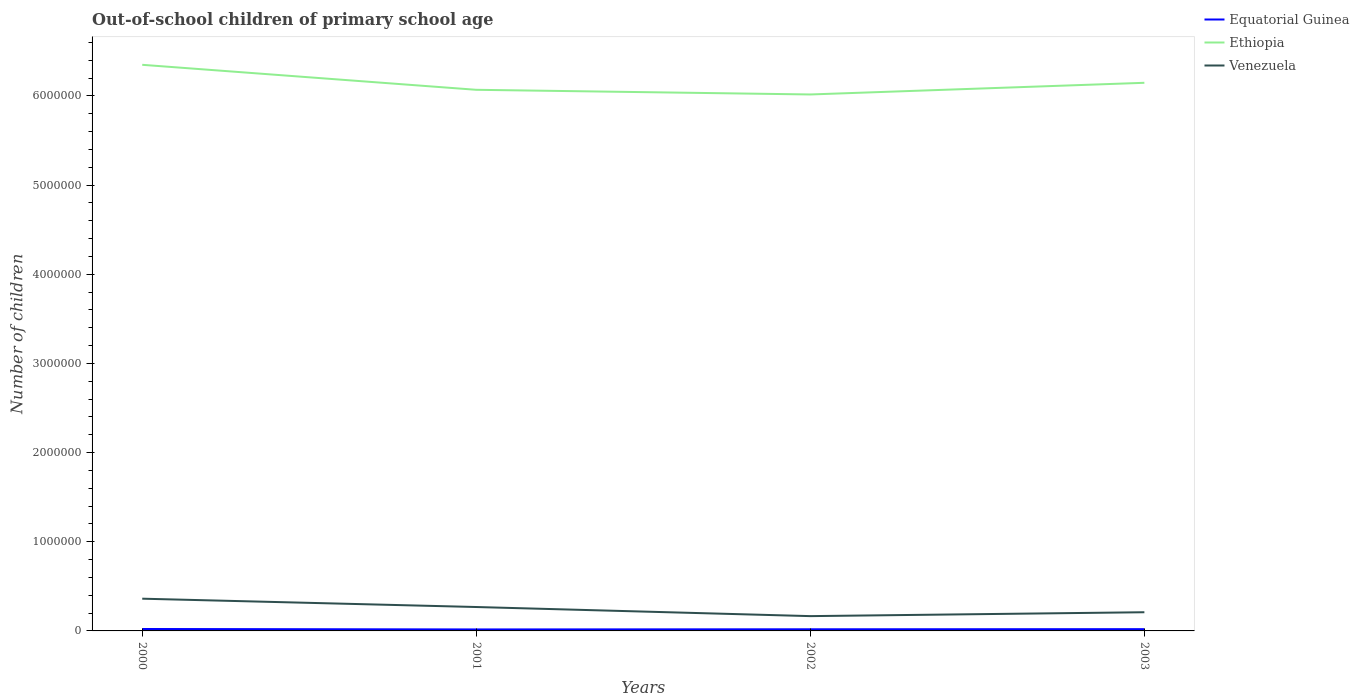How many different coloured lines are there?
Offer a terse response. 3. Does the line corresponding to Equatorial Guinea intersect with the line corresponding to Ethiopia?
Make the answer very short. No. Across all years, what is the maximum number of out-of-school children in Venezuela?
Give a very brief answer. 1.66e+05. What is the total number of out-of-school children in Ethiopia in the graph?
Offer a terse response. 5.23e+04. What is the difference between the highest and the second highest number of out-of-school children in Equatorial Guinea?
Ensure brevity in your answer.  4929. What is the difference between the highest and the lowest number of out-of-school children in Equatorial Guinea?
Offer a very short reply. 2. Is the number of out-of-school children in Equatorial Guinea strictly greater than the number of out-of-school children in Venezuela over the years?
Give a very brief answer. Yes. How many lines are there?
Ensure brevity in your answer.  3. What is the difference between two consecutive major ticks on the Y-axis?
Offer a terse response. 1.00e+06. Does the graph contain grids?
Your response must be concise. No. How are the legend labels stacked?
Keep it short and to the point. Vertical. What is the title of the graph?
Your answer should be very brief. Out-of-school children of primary school age. Does "Guatemala" appear as one of the legend labels in the graph?
Ensure brevity in your answer.  No. What is the label or title of the Y-axis?
Offer a terse response. Number of children. What is the Number of children in Equatorial Guinea in 2000?
Offer a terse response. 2.16e+04. What is the Number of children of Ethiopia in 2000?
Offer a terse response. 6.35e+06. What is the Number of children of Venezuela in 2000?
Offer a very short reply. 3.62e+05. What is the Number of children in Equatorial Guinea in 2001?
Keep it short and to the point. 1.67e+04. What is the Number of children of Ethiopia in 2001?
Ensure brevity in your answer.  6.07e+06. What is the Number of children in Venezuela in 2001?
Your answer should be compact. 2.68e+05. What is the Number of children of Equatorial Guinea in 2002?
Offer a very short reply. 1.84e+04. What is the Number of children of Ethiopia in 2002?
Give a very brief answer. 6.02e+06. What is the Number of children in Venezuela in 2002?
Provide a succinct answer. 1.66e+05. What is the Number of children in Equatorial Guinea in 2003?
Offer a very short reply. 1.98e+04. What is the Number of children of Ethiopia in 2003?
Provide a short and direct response. 6.15e+06. What is the Number of children of Venezuela in 2003?
Your answer should be very brief. 2.10e+05. Across all years, what is the maximum Number of children in Equatorial Guinea?
Provide a succinct answer. 2.16e+04. Across all years, what is the maximum Number of children of Ethiopia?
Give a very brief answer. 6.35e+06. Across all years, what is the maximum Number of children of Venezuela?
Ensure brevity in your answer.  3.62e+05. Across all years, what is the minimum Number of children of Equatorial Guinea?
Your answer should be compact. 1.67e+04. Across all years, what is the minimum Number of children of Ethiopia?
Give a very brief answer. 6.02e+06. Across all years, what is the minimum Number of children in Venezuela?
Keep it short and to the point. 1.66e+05. What is the total Number of children in Equatorial Guinea in the graph?
Make the answer very short. 7.65e+04. What is the total Number of children in Ethiopia in the graph?
Your answer should be compact. 2.46e+07. What is the total Number of children in Venezuela in the graph?
Make the answer very short. 1.01e+06. What is the difference between the Number of children of Equatorial Guinea in 2000 and that in 2001?
Your answer should be very brief. 4929. What is the difference between the Number of children of Ethiopia in 2000 and that in 2001?
Your response must be concise. 2.80e+05. What is the difference between the Number of children of Venezuela in 2000 and that in 2001?
Your response must be concise. 9.35e+04. What is the difference between the Number of children of Equatorial Guinea in 2000 and that in 2002?
Offer a very short reply. 3176. What is the difference between the Number of children in Ethiopia in 2000 and that in 2002?
Your response must be concise. 3.33e+05. What is the difference between the Number of children in Venezuela in 2000 and that in 2002?
Provide a short and direct response. 1.96e+05. What is the difference between the Number of children of Equatorial Guinea in 2000 and that in 2003?
Your response must be concise. 1792. What is the difference between the Number of children in Ethiopia in 2000 and that in 2003?
Offer a terse response. 2.02e+05. What is the difference between the Number of children in Venezuela in 2000 and that in 2003?
Ensure brevity in your answer.  1.52e+05. What is the difference between the Number of children in Equatorial Guinea in 2001 and that in 2002?
Provide a succinct answer. -1753. What is the difference between the Number of children in Ethiopia in 2001 and that in 2002?
Your answer should be compact. 5.23e+04. What is the difference between the Number of children of Venezuela in 2001 and that in 2002?
Provide a short and direct response. 1.02e+05. What is the difference between the Number of children in Equatorial Guinea in 2001 and that in 2003?
Keep it short and to the point. -3137. What is the difference between the Number of children in Ethiopia in 2001 and that in 2003?
Offer a very short reply. -7.86e+04. What is the difference between the Number of children in Venezuela in 2001 and that in 2003?
Ensure brevity in your answer.  5.85e+04. What is the difference between the Number of children of Equatorial Guinea in 2002 and that in 2003?
Offer a terse response. -1384. What is the difference between the Number of children in Ethiopia in 2002 and that in 2003?
Your answer should be very brief. -1.31e+05. What is the difference between the Number of children in Venezuela in 2002 and that in 2003?
Provide a short and direct response. -4.36e+04. What is the difference between the Number of children of Equatorial Guinea in 2000 and the Number of children of Ethiopia in 2001?
Your answer should be very brief. -6.05e+06. What is the difference between the Number of children in Equatorial Guinea in 2000 and the Number of children in Venezuela in 2001?
Make the answer very short. -2.47e+05. What is the difference between the Number of children in Ethiopia in 2000 and the Number of children in Venezuela in 2001?
Give a very brief answer. 6.08e+06. What is the difference between the Number of children of Equatorial Guinea in 2000 and the Number of children of Ethiopia in 2002?
Offer a terse response. -5.99e+06. What is the difference between the Number of children of Equatorial Guinea in 2000 and the Number of children of Venezuela in 2002?
Provide a succinct answer. -1.44e+05. What is the difference between the Number of children in Ethiopia in 2000 and the Number of children in Venezuela in 2002?
Offer a very short reply. 6.18e+06. What is the difference between the Number of children of Equatorial Guinea in 2000 and the Number of children of Ethiopia in 2003?
Provide a short and direct response. -6.13e+06. What is the difference between the Number of children in Equatorial Guinea in 2000 and the Number of children in Venezuela in 2003?
Provide a short and direct response. -1.88e+05. What is the difference between the Number of children of Ethiopia in 2000 and the Number of children of Venezuela in 2003?
Your answer should be compact. 6.14e+06. What is the difference between the Number of children of Equatorial Guinea in 2001 and the Number of children of Ethiopia in 2002?
Give a very brief answer. -6.00e+06. What is the difference between the Number of children of Equatorial Guinea in 2001 and the Number of children of Venezuela in 2002?
Offer a very short reply. -1.49e+05. What is the difference between the Number of children of Ethiopia in 2001 and the Number of children of Venezuela in 2002?
Offer a terse response. 5.90e+06. What is the difference between the Number of children of Equatorial Guinea in 2001 and the Number of children of Ethiopia in 2003?
Your answer should be very brief. -6.13e+06. What is the difference between the Number of children in Equatorial Guinea in 2001 and the Number of children in Venezuela in 2003?
Keep it short and to the point. -1.93e+05. What is the difference between the Number of children in Ethiopia in 2001 and the Number of children in Venezuela in 2003?
Offer a very short reply. 5.86e+06. What is the difference between the Number of children of Equatorial Guinea in 2002 and the Number of children of Ethiopia in 2003?
Ensure brevity in your answer.  -6.13e+06. What is the difference between the Number of children of Equatorial Guinea in 2002 and the Number of children of Venezuela in 2003?
Your answer should be compact. -1.91e+05. What is the difference between the Number of children of Ethiopia in 2002 and the Number of children of Venezuela in 2003?
Your response must be concise. 5.81e+06. What is the average Number of children in Equatorial Guinea per year?
Offer a very short reply. 1.91e+04. What is the average Number of children in Ethiopia per year?
Ensure brevity in your answer.  6.15e+06. What is the average Number of children in Venezuela per year?
Offer a very short reply. 2.51e+05. In the year 2000, what is the difference between the Number of children in Equatorial Guinea and Number of children in Ethiopia?
Ensure brevity in your answer.  -6.33e+06. In the year 2000, what is the difference between the Number of children in Equatorial Guinea and Number of children in Venezuela?
Your response must be concise. -3.40e+05. In the year 2000, what is the difference between the Number of children in Ethiopia and Number of children in Venezuela?
Your answer should be very brief. 5.99e+06. In the year 2001, what is the difference between the Number of children of Equatorial Guinea and Number of children of Ethiopia?
Keep it short and to the point. -6.05e+06. In the year 2001, what is the difference between the Number of children of Equatorial Guinea and Number of children of Venezuela?
Provide a succinct answer. -2.51e+05. In the year 2001, what is the difference between the Number of children of Ethiopia and Number of children of Venezuela?
Your answer should be very brief. 5.80e+06. In the year 2002, what is the difference between the Number of children in Equatorial Guinea and Number of children in Ethiopia?
Offer a very short reply. -6.00e+06. In the year 2002, what is the difference between the Number of children in Equatorial Guinea and Number of children in Venezuela?
Provide a short and direct response. -1.48e+05. In the year 2002, what is the difference between the Number of children in Ethiopia and Number of children in Venezuela?
Give a very brief answer. 5.85e+06. In the year 2003, what is the difference between the Number of children in Equatorial Guinea and Number of children in Ethiopia?
Your response must be concise. -6.13e+06. In the year 2003, what is the difference between the Number of children of Equatorial Guinea and Number of children of Venezuela?
Make the answer very short. -1.90e+05. In the year 2003, what is the difference between the Number of children in Ethiopia and Number of children in Venezuela?
Ensure brevity in your answer.  5.94e+06. What is the ratio of the Number of children in Equatorial Guinea in 2000 to that in 2001?
Your response must be concise. 1.3. What is the ratio of the Number of children of Ethiopia in 2000 to that in 2001?
Offer a terse response. 1.05. What is the ratio of the Number of children of Venezuela in 2000 to that in 2001?
Make the answer very short. 1.35. What is the ratio of the Number of children of Equatorial Guinea in 2000 to that in 2002?
Offer a very short reply. 1.17. What is the ratio of the Number of children in Ethiopia in 2000 to that in 2002?
Your answer should be compact. 1.06. What is the ratio of the Number of children of Venezuela in 2000 to that in 2002?
Offer a terse response. 2.18. What is the ratio of the Number of children in Equatorial Guinea in 2000 to that in 2003?
Offer a terse response. 1.09. What is the ratio of the Number of children of Ethiopia in 2000 to that in 2003?
Provide a short and direct response. 1.03. What is the ratio of the Number of children of Venezuela in 2000 to that in 2003?
Offer a very short reply. 1.73. What is the ratio of the Number of children of Equatorial Guinea in 2001 to that in 2002?
Provide a succinct answer. 0.9. What is the ratio of the Number of children in Ethiopia in 2001 to that in 2002?
Offer a terse response. 1.01. What is the ratio of the Number of children of Venezuela in 2001 to that in 2002?
Offer a very short reply. 1.62. What is the ratio of the Number of children of Equatorial Guinea in 2001 to that in 2003?
Ensure brevity in your answer.  0.84. What is the ratio of the Number of children in Ethiopia in 2001 to that in 2003?
Provide a succinct answer. 0.99. What is the ratio of the Number of children of Venezuela in 2001 to that in 2003?
Ensure brevity in your answer.  1.28. What is the ratio of the Number of children of Equatorial Guinea in 2002 to that in 2003?
Provide a succinct answer. 0.93. What is the ratio of the Number of children in Ethiopia in 2002 to that in 2003?
Offer a terse response. 0.98. What is the ratio of the Number of children in Venezuela in 2002 to that in 2003?
Provide a succinct answer. 0.79. What is the difference between the highest and the second highest Number of children in Equatorial Guinea?
Your answer should be very brief. 1792. What is the difference between the highest and the second highest Number of children in Ethiopia?
Your answer should be very brief. 2.02e+05. What is the difference between the highest and the second highest Number of children of Venezuela?
Give a very brief answer. 9.35e+04. What is the difference between the highest and the lowest Number of children in Equatorial Guinea?
Your response must be concise. 4929. What is the difference between the highest and the lowest Number of children in Ethiopia?
Provide a succinct answer. 3.33e+05. What is the difference between the highest and the lowest Number of children of Venezuela?
Make the answer very short. 1.96e+05. 